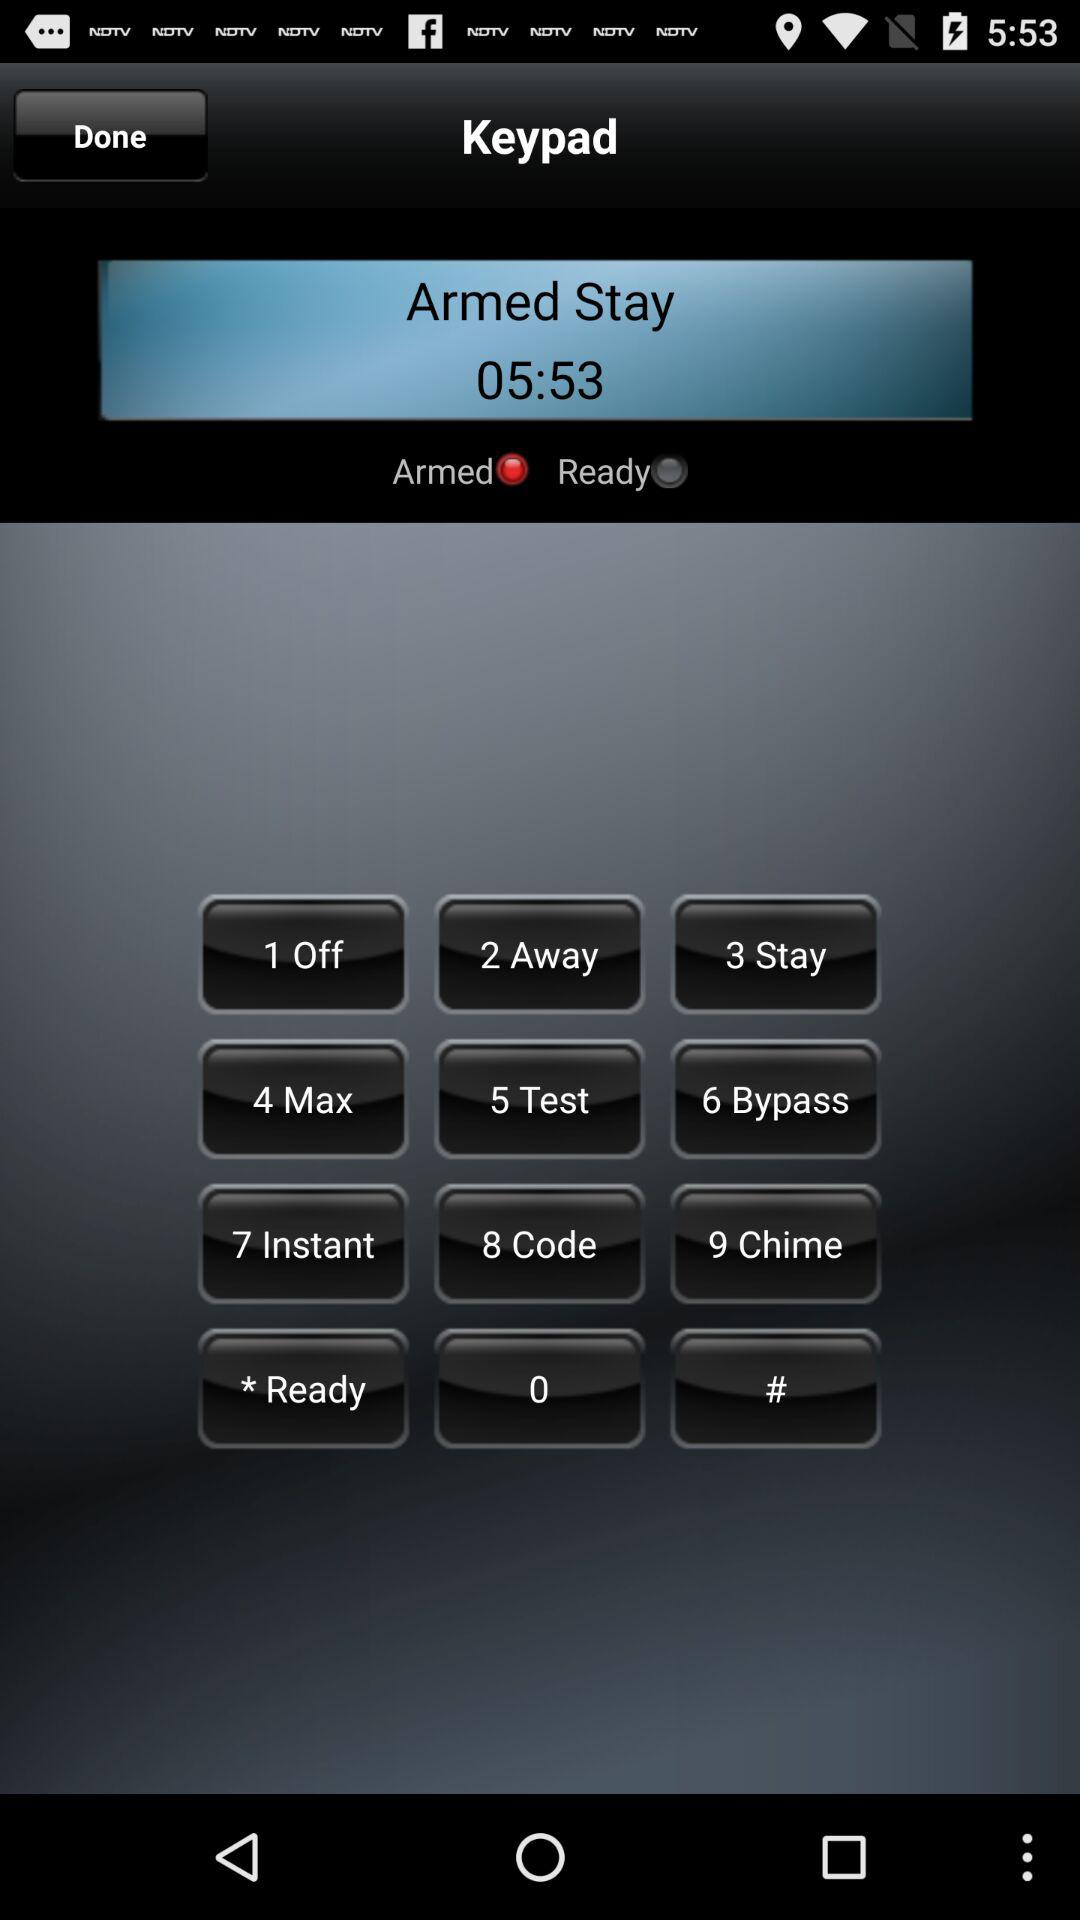What timer has been selected? The selected timer is "Armed". 